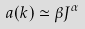<formula> <loc_0><loc_0><loc_500><loc_500>a ( { k } ) \simeq \beta J ^ { \alpha }</formula> 